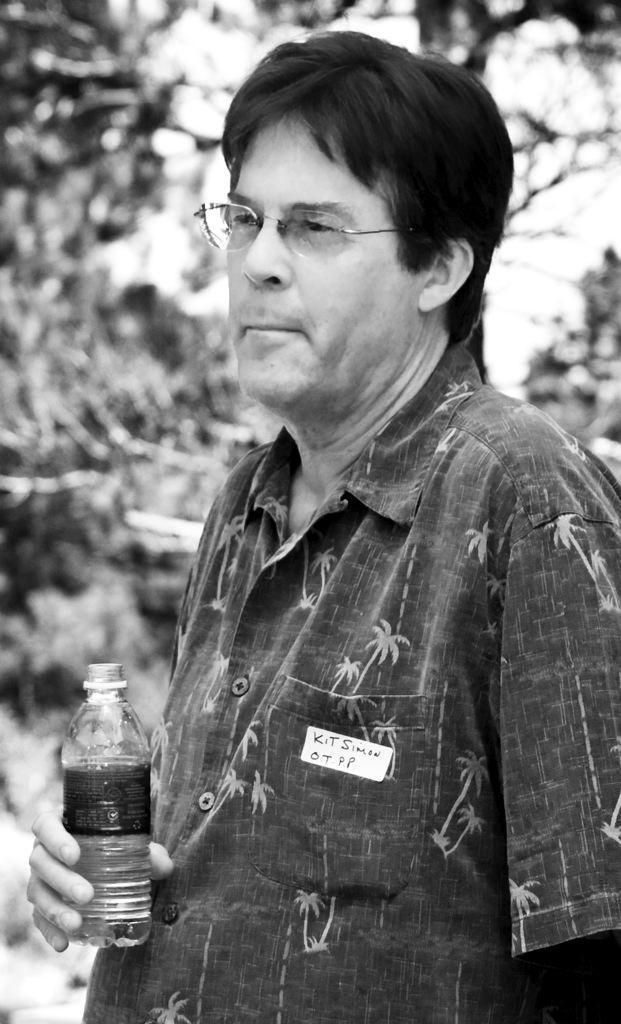How would you summarize this image in a sentence or two? This picture shows a man wearing a shirt and spectacles holding a water bottle in his hands. In the background there is a tree. 